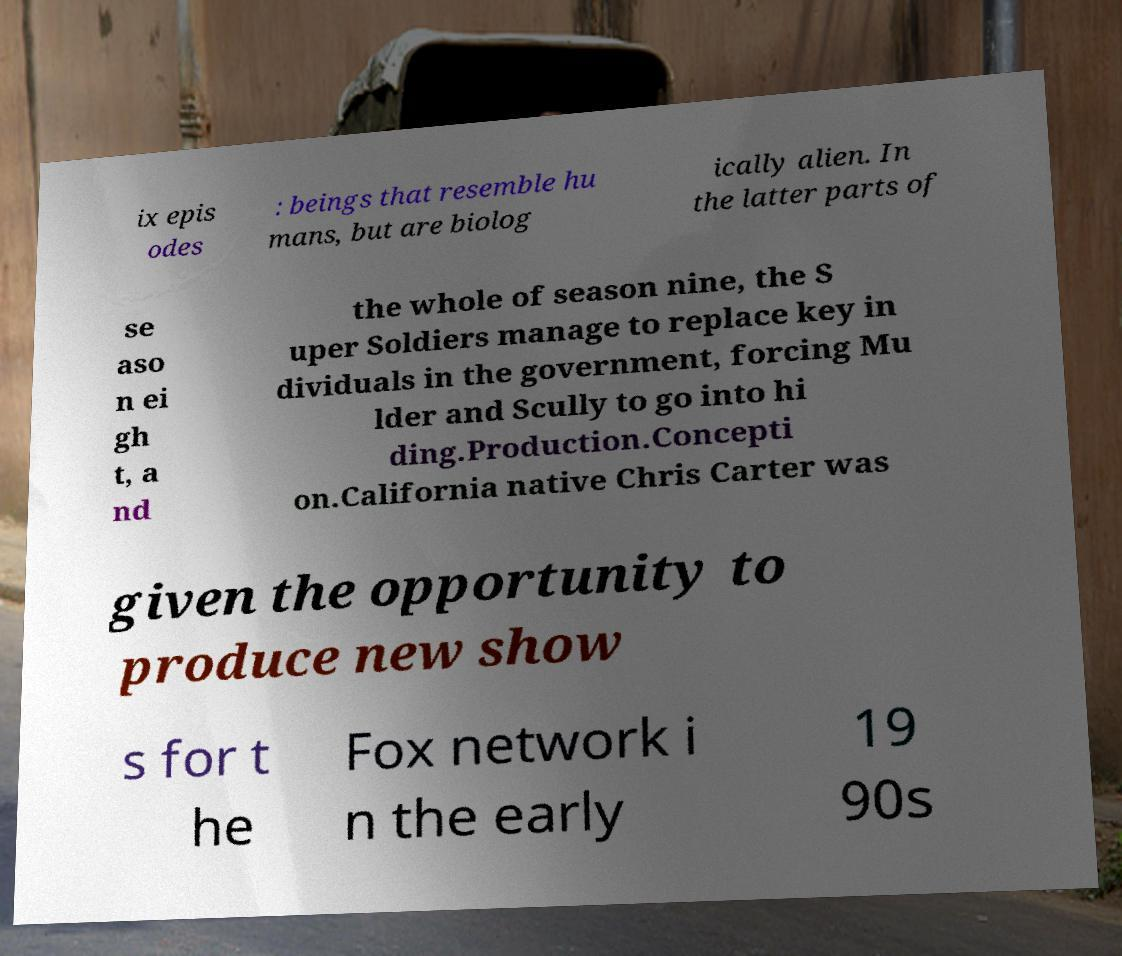Could you extract and type out the text from this image? ix epis odes : beings that resemble hu mans, but are biolog ically alien. In the latter parts of se aso n ei gh t, a nd the whole of season nine, the S uper Soldiers manage to replace key in dividuals in the government, forcing Mu lder and Scully to go into hi ding.Production.Concepti on.California native Chris Carter was given the opportunity to produce new show s for t he Fox network i n the early 19 90s 